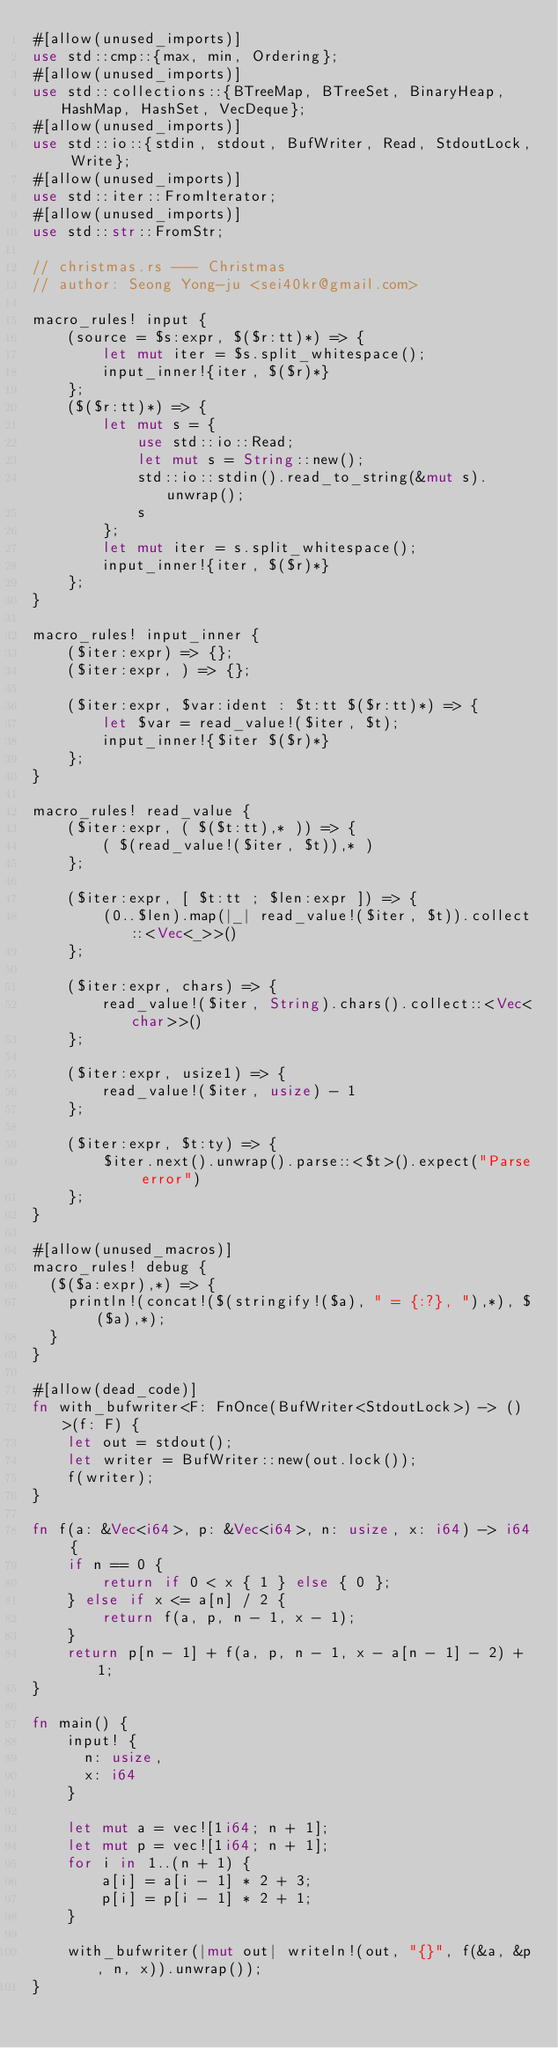<code> <loc_0><loc_0><loc_500><loc_500><_Rust_>#[allow(unused_imports)]
use std::cmp::{max, min, Ordering};
#[allow(unused_imports)]
use std::collections::{BTreeMap, BTreeSet, BinaryHeap, HashMap, HashSet, VecDeque};
#[allow(unused_imports)]
use std::io::{stdin, stdout, BufWriter, Read, StdoutLock, Write};
#[allow(unused_imports)]
use std::iter::FromIterator;
#[allow(unused_imports)]
use std::str::FromStr;

// christmas.rs --- Christmas
// author: Seong Yong-ju <sei40kr@gmail.com>

macro_rules! input {
    (source = $s:expr, $($r:tt)*) => {
        let mut iter = $s.split_whitespace();
        input_inner!{iter, $($r)*}
    };
    ($($r:tt)*) => {
        let mut s = {
            use std::io::Read;
            let mut s = String::new();
            std::io::stdin().read_to_string(&mut s).unwrap();
            s
        };
        let mut iter = s.split_whitespace();
        input_inner!{iter, $($r)*}
    };
}

macro_rules! input_inner {
    ($iter:expr) => {};
    ($iter:expr, ) => {};

    ($iter:expr, $var:ident : $t:tt $($r:tt)*) => {
        let $var = read_value!($iter, $t);
        input_inner!{$iter $($r)*}
    };
}

macro_rules! read_value {
    ($iter:expr, ( $($t:tt),* )) => {
        ( $(read_value!($iter, $t)),* )
    };

    ($iter:expr, [ $t:tt ; $len:expr ]) => {
        (0..$len).map(|_| read_value!($iter, $t)).collect::<Vec<_>>()
    };

    ($iter:expr, chars) => {
        read_value!($iter, String).chars().collect::<Vec<char>>()
    };

    ($iter:expr, usize1) => {
        read_value!($iter, usize) - 1
    };

    ($iter:expr, $t:ty) => {
        $iter.next().unwrap().parse::<$t>().expect("Parse error")
    };
}

#[allow(unused_macros)]
macro_rules! debug {
  ($($a:expr),*) => {
    println!(concat!($(stringify!($a), " = {:?}, "),*), $($a),*);
  }
}

#[allow(dead_code)]
fn with_bufwriter<F: FnOnce(BufWriter<StdoutLock>) -> ()>(f: F) {
    let out = stdout();
    let writer = BufWriter::new(out.lock());
    f(writer);
}

fn f(a: &Vec<i64>, p: &Vec<i64>, n: usize, x: i64) -> i64 {
    if n == 0 {
        return if 0 < x { 1 } else { 0 };
    } else if x <= a[n] / 2 {
        return f(a, p, n - 1, x - 1);
    }
    return p[n - 1] + f(a, p, n - 1, x - a[n - 1] - 2) + 1;
}

fn main() {
    input! {
      n: usize,
      x: i64
    }

    let mut a = vec![1i64; n + 1];
    let mut p = vec![1i64; n + 1];
    for i in 1..(n + 1) {
        a[i] = a[i - 1] * 2 + 3;
        p[i] = p[i - 1] * 2 + 1;
    }

    with_bufwriter(|mut out| writeln!(out, "{}", f(&a, &p, n, x)).unwrap());
}
</code> 